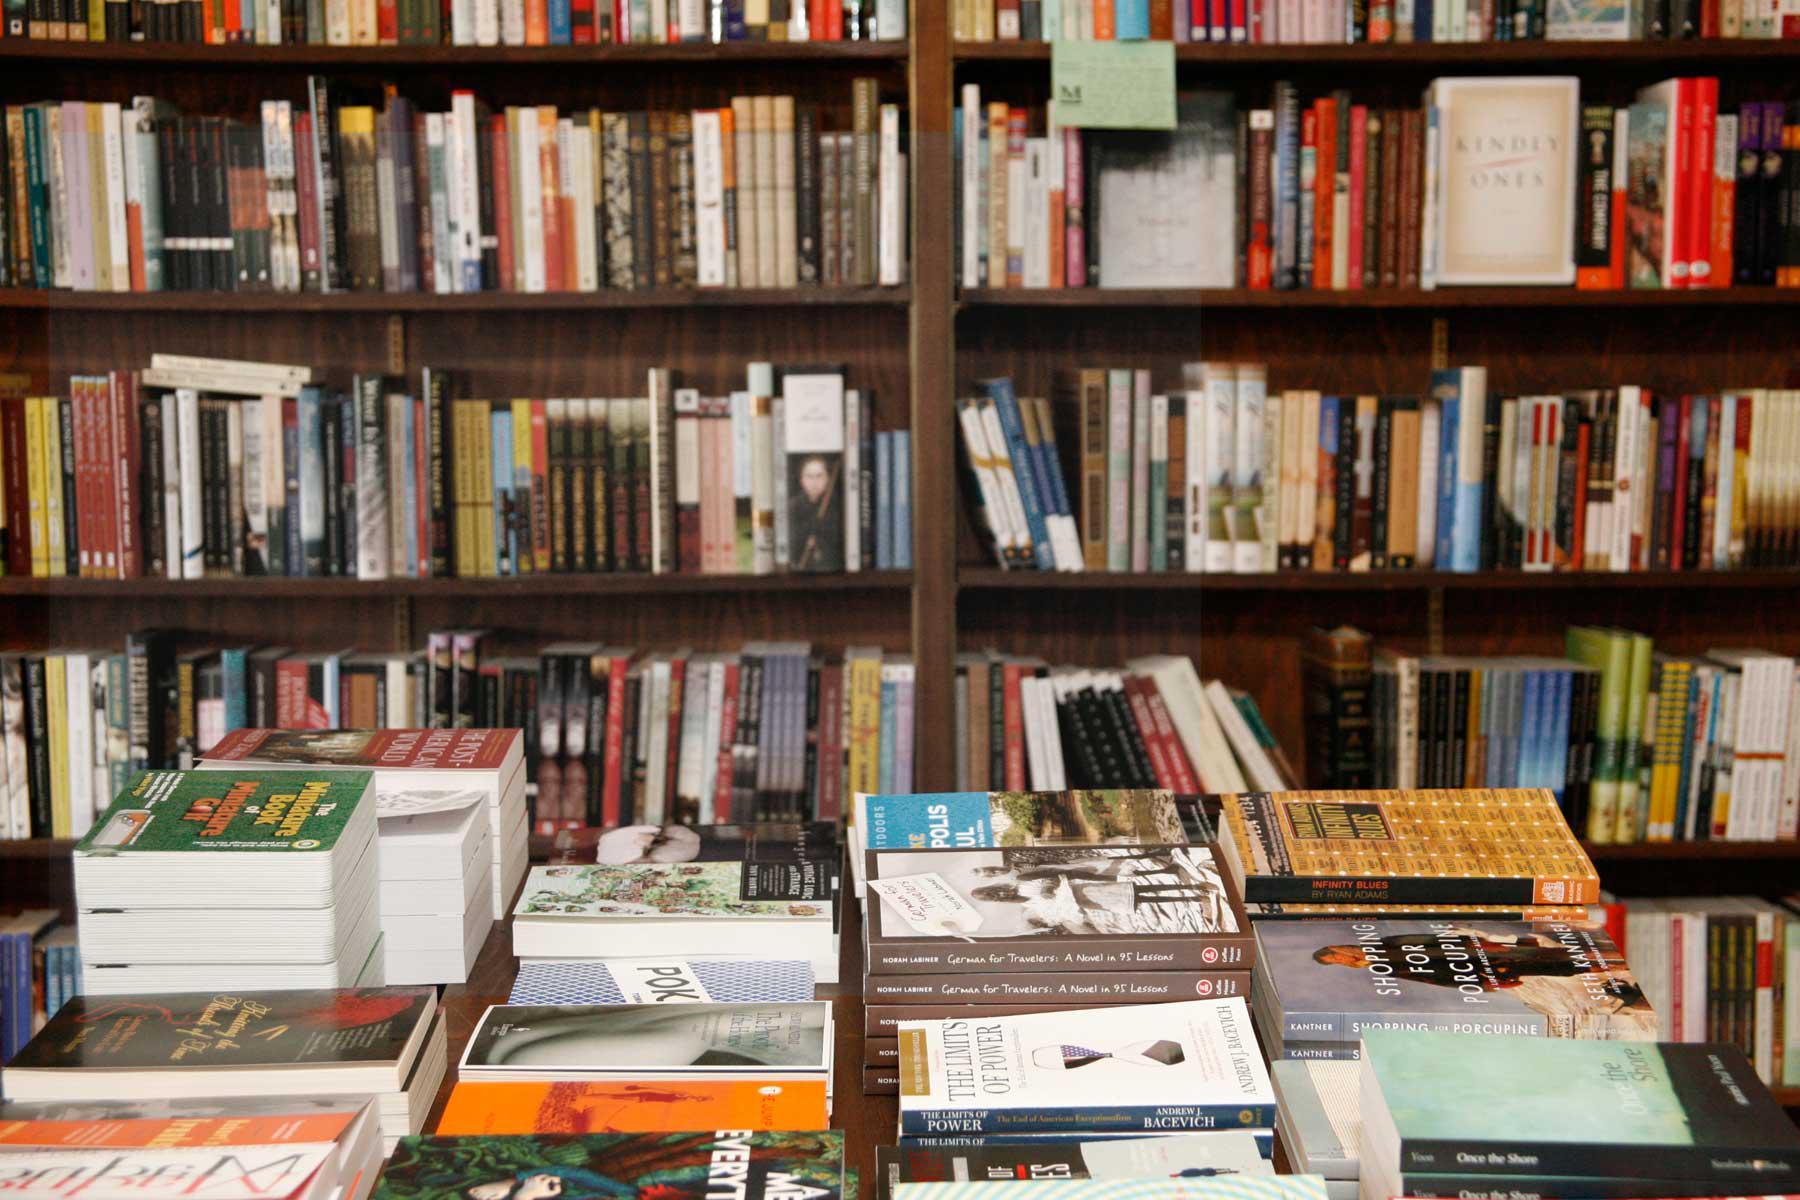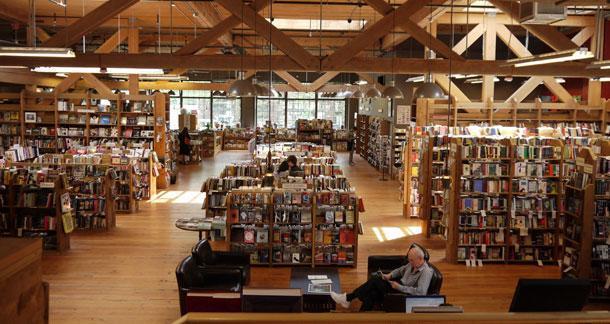The first image is the image on the left, the second image is the image on the right. Given the left and right images, does the statement "The right image has visible windows, the left does not." hold true? Answer yes or no. Yes. 